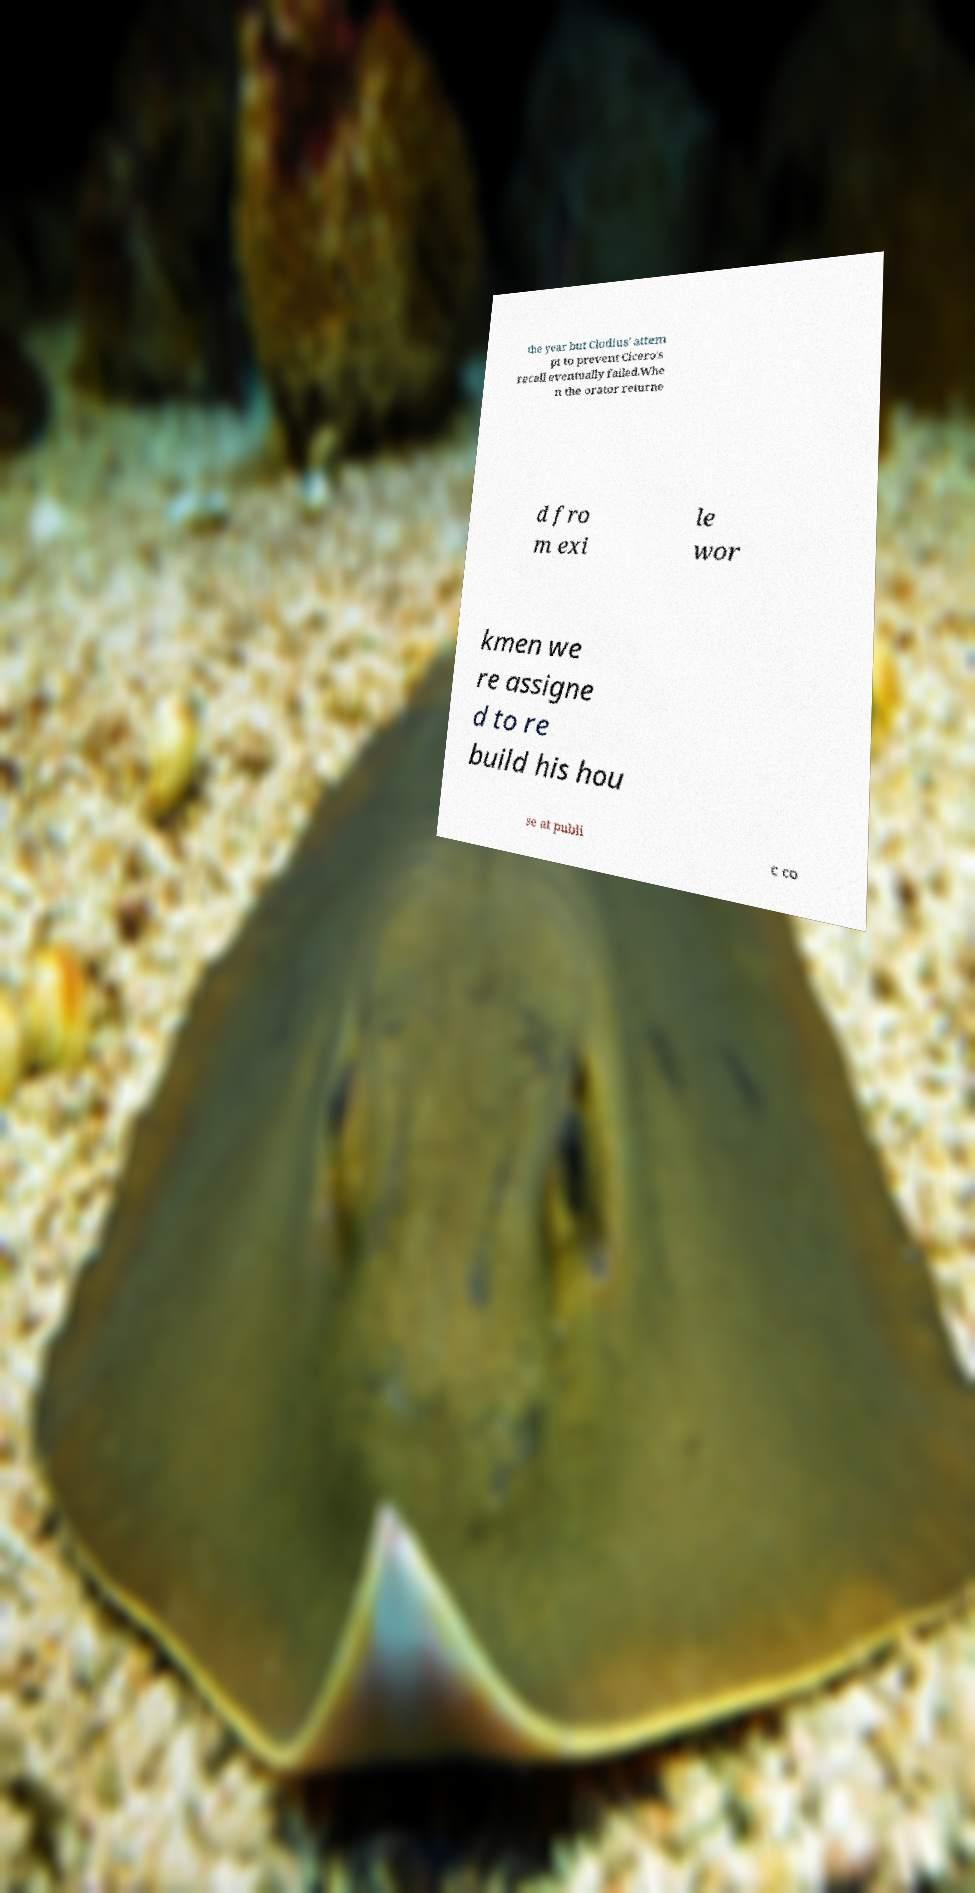Please read and relay the text visible in this image. What does it say? the year but Clodius' attem pt to prevent Cicero's recall eventually failed.Whe n the orator returne d fro m exi le wor kmen we re assigne d to re build his hou se at publi c co 